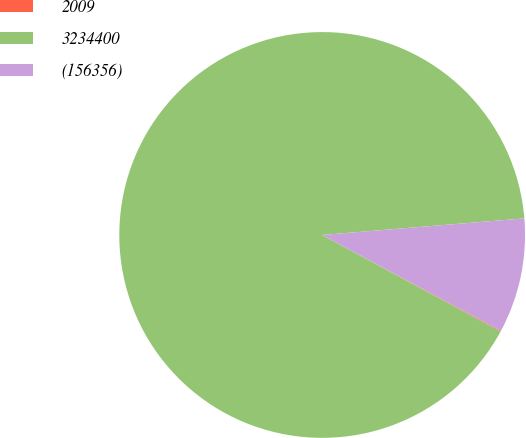<chart> <loc_0><loc_0><loc_500><loc_500><pie_chart><fcel>2009<fcel>3234400<fcel>(156356)<nl><fcel>0.06%<fcel>90.8%<fcel>9.14%<nl></chart> 